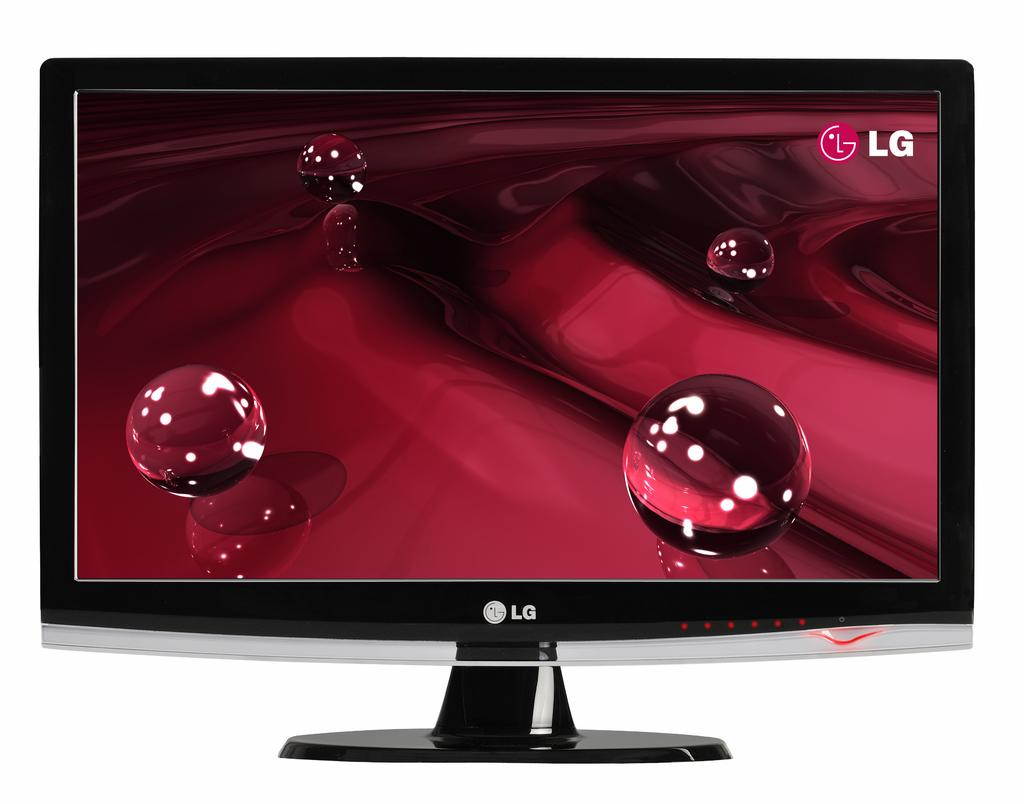<image>
Relay a brief, clear account of the picture shown. A television is on and has a LG logo on it. 